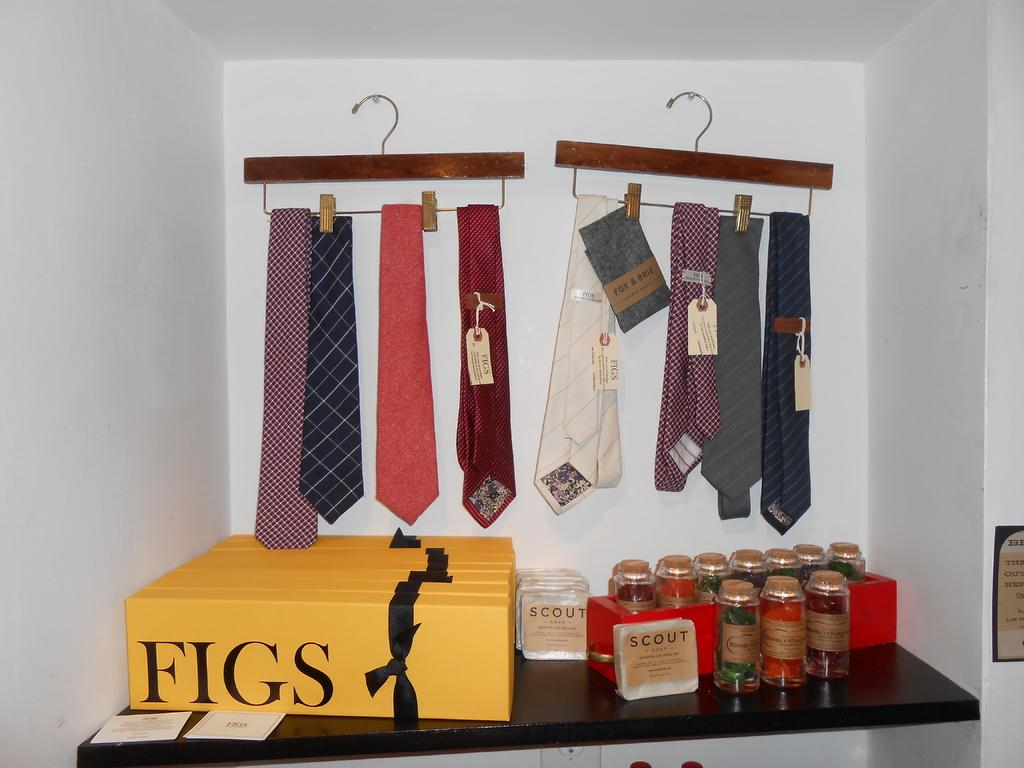Provide a one-sentence caption for the provided image. Several ties are hanging up in the background and there are yellow boxes out that say "FIGS". 